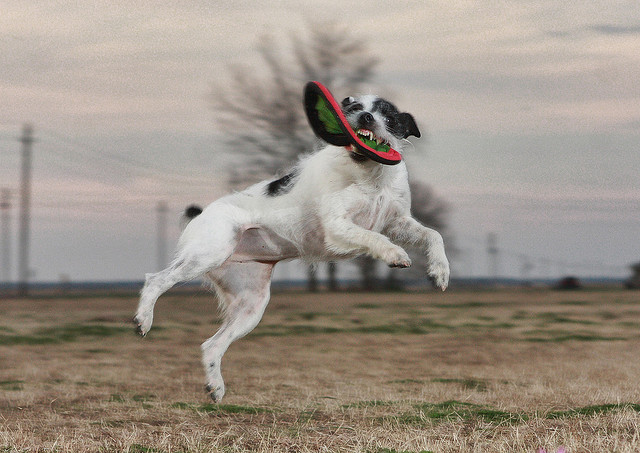Describe the landscape in the background. The background features a flat landscape with sparse vegetation, most likely a field. There are also distant powerlines and a tree line under a vast expanse of a cloud-streaked sky, indicating a rural or open area. Could this type of environment have an effect on the dog's behavior? Absolutely. Open fields provide plenty of space for dogs like Border Collies to exercise and indulge in fetching games like the one shown. Such environments are beneficial for high-energy breeds that require ample space to run and play. 